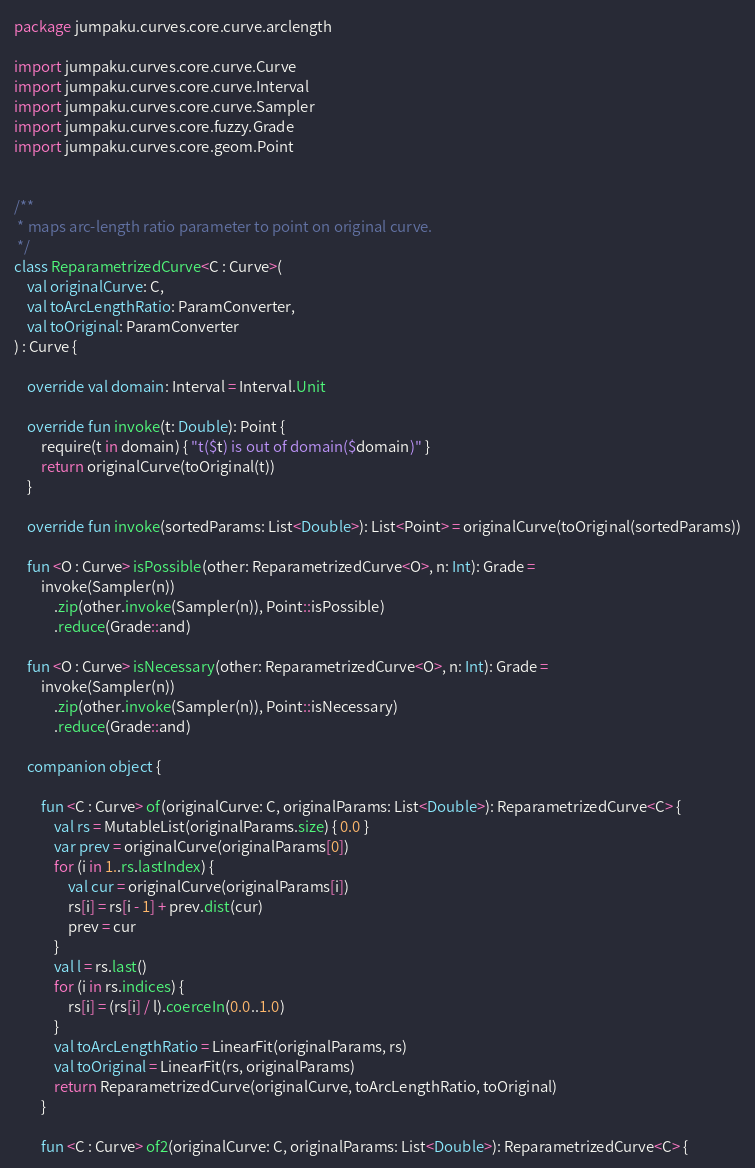<code> <loc_0><loc_0><loc_500><loc_500><_Kotlin_>package jumpaku.curves.core.curve.arclength

import jumpaku.curves.core.curve.Curve
import jumpaku.curves.core.curve.Interval
import jumpaku.curves.core.curve.Sampler
import jumpaku.curves.core.fuzzy.Grade
import jumpaku.curves.core.geom.Point


/**
 * maps arc-length ratio parameter to point on original curve.
 */
class ReparametrizedCurve<C : Curve>(
    val originalCurve: C,
    val toArcLengthRatio: ParamConverter,
    val toOriginal: ParamConverter
) : Curve {

    override val domain: Interval = Interval.Unit

    override fun invoke(t: Double): Point {
        require(t in domain) { "t($t) is out of domain($domain)" }
        return originalCurve(toOriginal(t))
    }

    override fun invoke(sortedParams: List<Double>): List<Point> = originalCurve(toOriginal(sortedParams))

    fun <O : Curve> isPossible(other: ReparametrizedCurve<O>, n: Int): Grade =
        invoke(Sampler(n))
            .zip(other.invoke(Sampler(n)), Point::isPossible)
            .reduce(Grade::and)

    fun <O : Curve> isNecessary(other: ReparametrizedCurve<O>, n: Int): Grade =
        invoke(Sampler(n))
            .zip(other.invoke(Sampler(n)), Point::isNecessary)
            .reduce(Grade::and)

    companion object {

        fun <C : Curve> of(originalCurve: C, originalParams: List<Double>): ReparametrizedCurve<C> {
            val rs = MutableList(originalParams.size) { 0.0 }
            var prev = originalCurve(originalParams[0])
            for (i in 1..rs.lastIndex) {
                val cur = originalCurve(originalParams[i])
                rs[i] = rs[i - 1] + prev.dist(cur)
                prev = cur
            }
            val l = rs.last()
            for (i in rs.indices) {
                rs[i] = (rs[i] / l).coerceIn(0.0..1.0)
            }
            val toArcLengthRatio = LinearFit(originalParams, rs)
            val toOriginal = LinearFit(rs, originalParams)
            return ReparametrizedCurve(originalCurve, toArcLengthRatio, toOriginal)
        }

        fun <C : Curve> of2(originalCurve: C, originalParams: List<Double>): ReparametrizedCurve<C> {</code> 